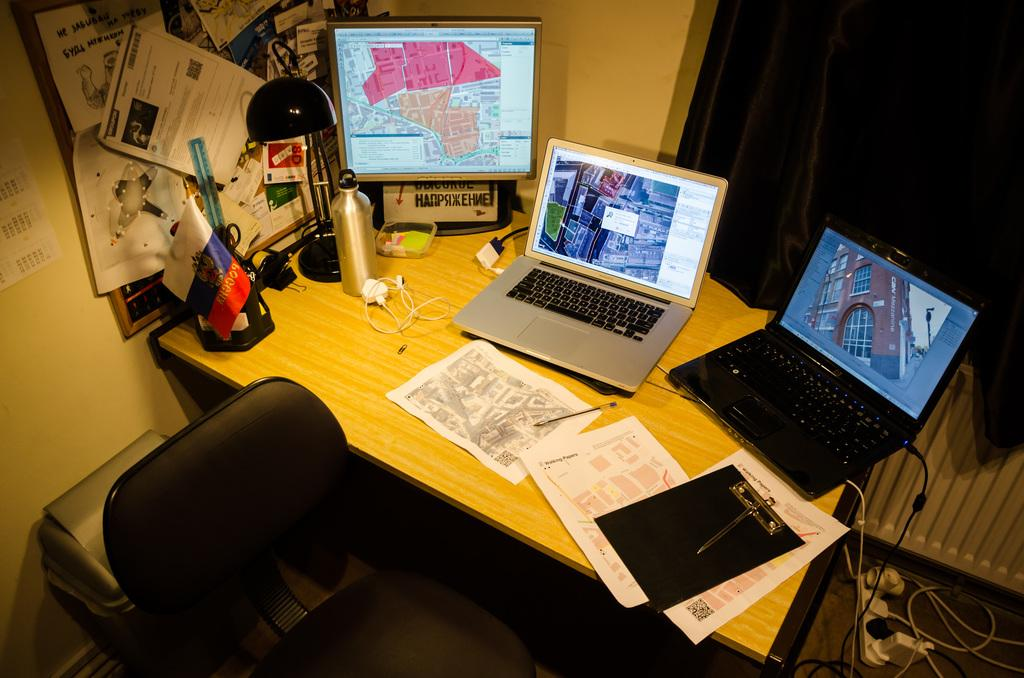How many laptops are on the table in the image? There are three laptops on the table in the image. What type of furniture is in the image? There is a chair in the image. What can be used for disposing of waste in the image? There is a dustbin in the image. What might be used for connecting the laptops to a power source or the internet? Cable wires are present in the image. What type of stationery item is on the table? There is a pad on the table. What can be used for holding liquids in the image? There is a bottle on the table. What can be seen as a decorative or symbolic item on the table? There is a flag on the table. What type of ring is visible on the table in the image? There is no ring present in the image. What type of dress is being worn by the laptop in the image? Laptops do not wear dresses, as they are inanimate objects. 